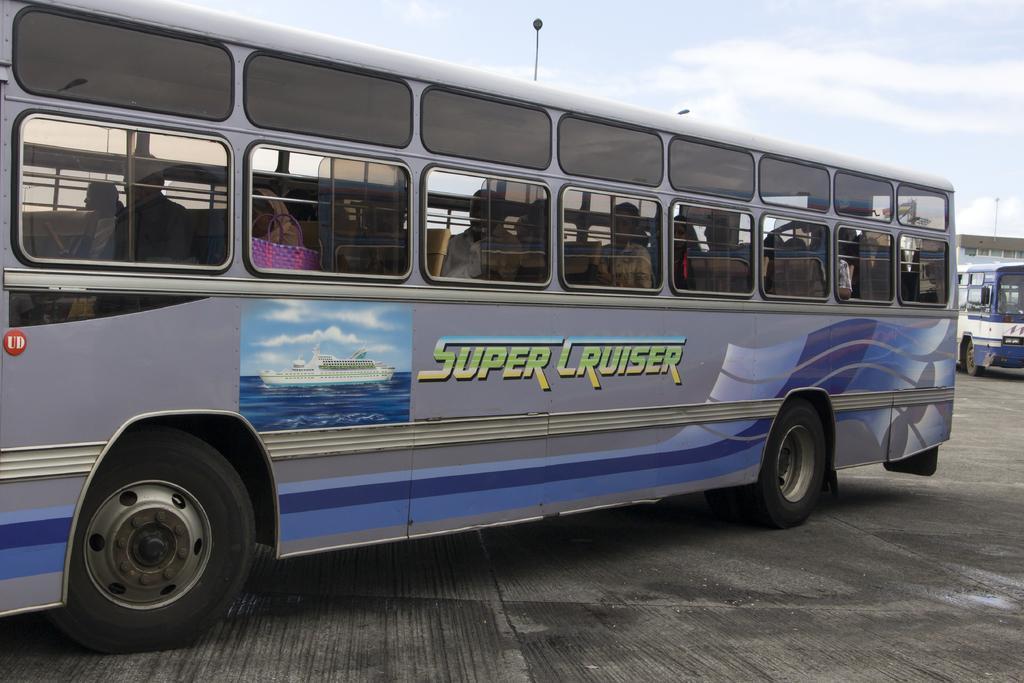Could you give a brief overview of what you see in this image? In this picture we can see a few people in the vehicle visible on the road. We can see a bus, a building and the cloudy sky. 